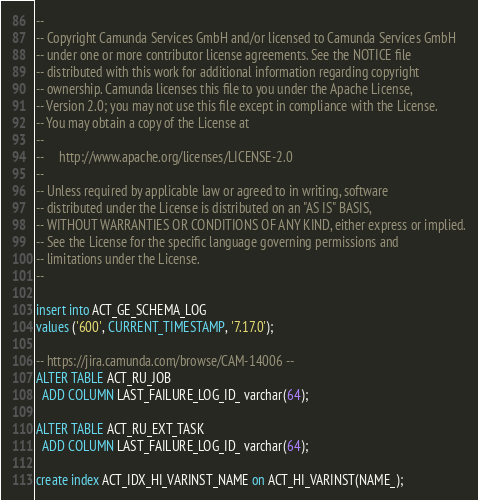Convert code to text. <code><loc_0><loc_0><loc_500><loc_500><_SQL_>--
-- Copyright Camunda Services GmbH and/or licensed to Camunda Services GmbH
-- under one or more contributor license agreements. See the NOTICE file
-- distributed with this work for additional information regarding copyright
-- ownership. Camunda licenses this file to you under the Apache License,
-- Version 2.0; you may not use this file except in compliance with the License.
-- You may obtain a copy of the License at
--
--     http://www.apache.org/licenses/LICENSE-2.0
--
-- Unless required by applicable law or agreed to in writing, software
-- distributed under the License is distributed on an "AS IS" BASIS,
-- WITHOUT WARRANTIES OR CONDITIONS OF ANY KIND, either express or implied.
-- See the License for the specific language governing permissions and
-- limitations under the License.
--

insert into ACT_GE_SCHEMA_LOG
values ('600', CURRENT_TIMESTAMP, '7.17.0');

-- https://jira.camunda.com/browse/CAM-14006 --
ALTER TABLE ACT_RU_JOB 
  ADD COLUMN LAST_FAILURE_LOG_ID_ varchar(64);
  
ALTER TABLE ACT_RU_EXT_TASK 
  ADD COLUMN LAST_FAILURE_LOG_ID_ varchar(64);

create index ACT_IDX_HI_VARINST_NAME on ACT_HI_VARINST(NAME_);</code> 